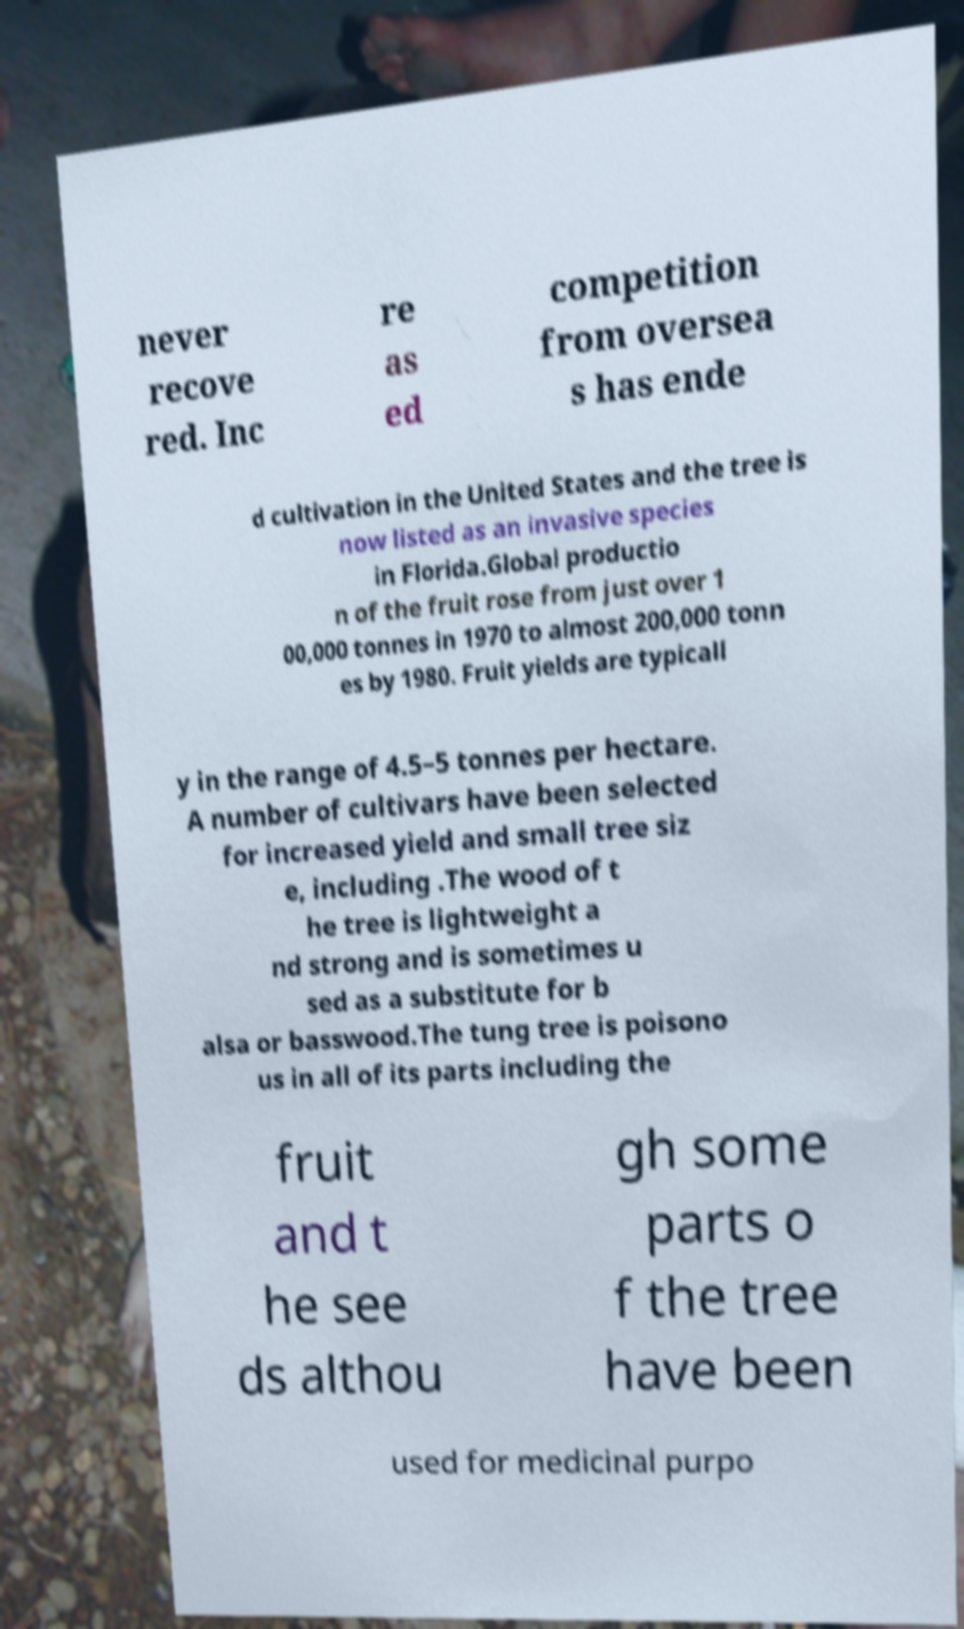What messages or text are displayed in this image? I need them in a readable, typed format. never recove red. Inc re as ed competition from oversea s has ende d cultivation in the United States and the tree is now listed as an invasive species in Florida.Global productio n of the fruit rose from just over 1 00,000 tonnes in 1970 to almost 200,000 tonn es by 1980. Fruit yields are typicall y in the range of 4.5–5 tonnes per hectare. A number of cultivars have been selected for increased yield and small tree siz e, including .The wood of t he tree is lightweight a nd strong and is sometimes u sed as a substitute for b alsa or basswood.The tung tree is poisono us in all of its parts including the fruit and t he see ds althou gh some parts o f the tree have been used for medicinal purpo 